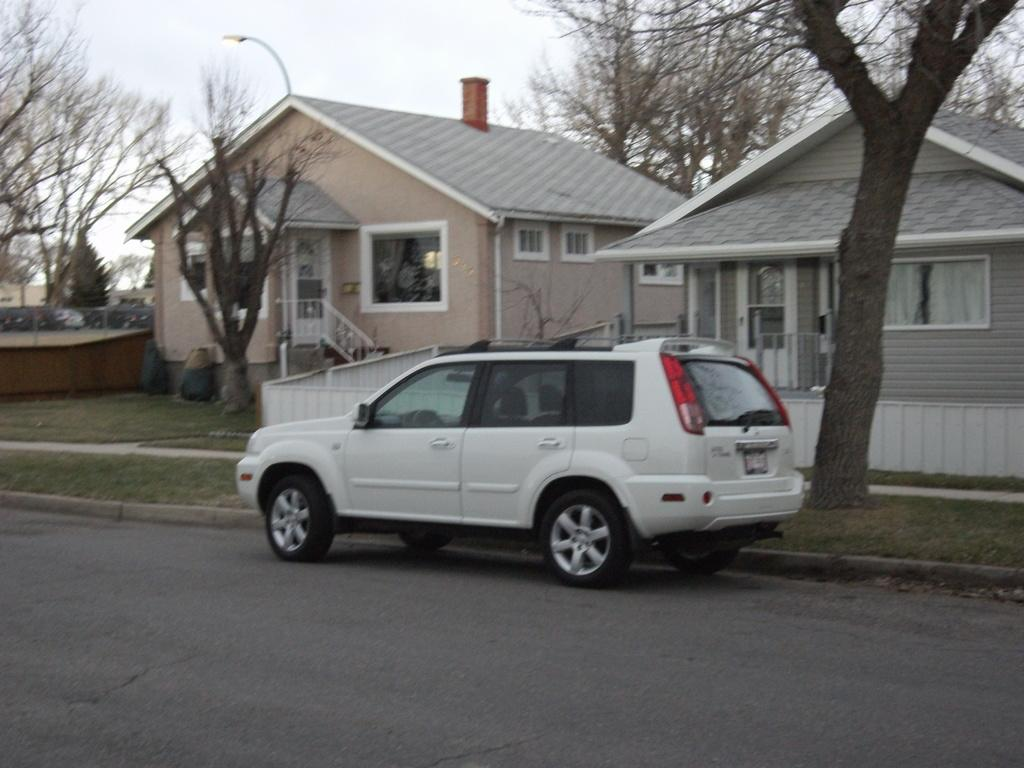What is the main feature of the image? There is a road in the image. What type of vehicle can be seen on the road? There is a white car in the image. What other elements are present in the image besides the road and car? There are trees and buildings in the image. Can you describe the color of the buildings? The buildings are cream and grey in color. What is visible in the background of the image? The sky is visible in the background of the image. Where is the sofa located in the image? There is no sofa present in the image. What type of vest is the person wearing in the image? There is no person or vest present in the image. 